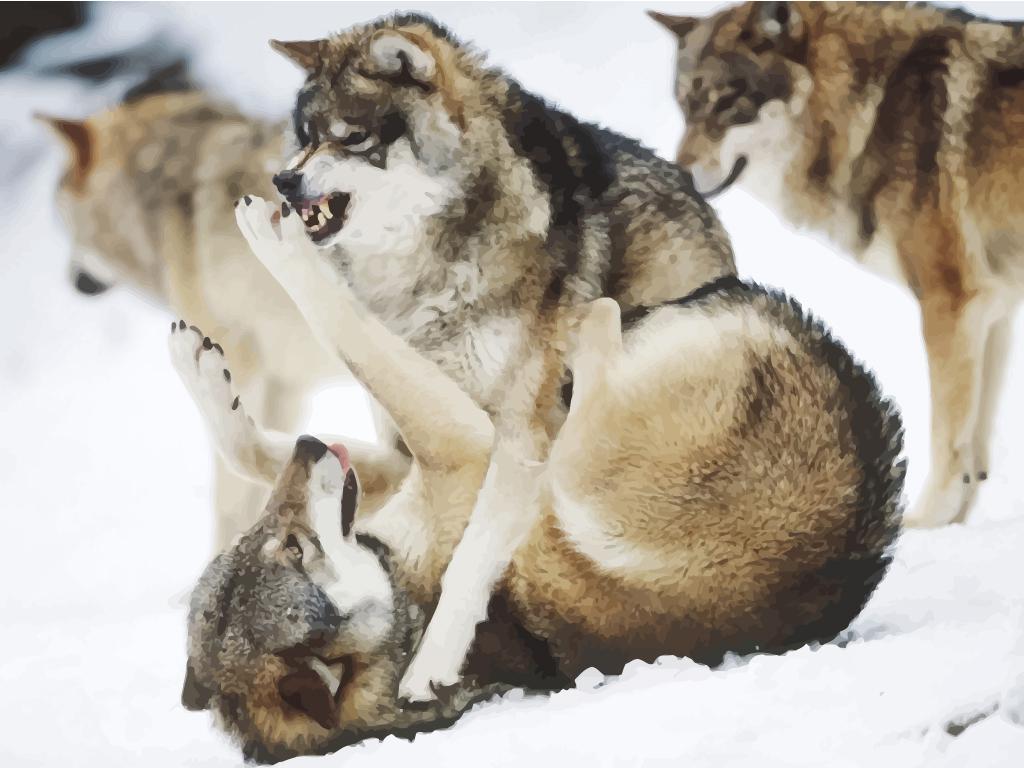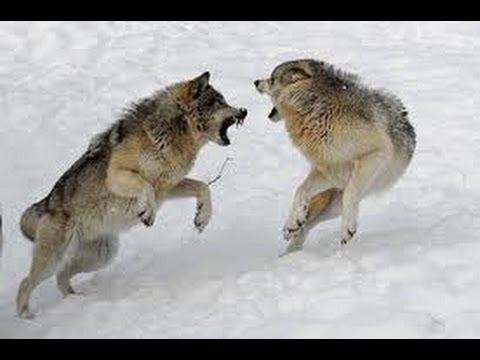The first image is the image on the left, the second image is the image on the right. Evaluate the accuracy of this statement regarding the images: "One image contains no more than one wolf.". Is it true? Answer yes or no. No. The first image is the image on the left, the second image is the image on the right. Analyze the images presented: Is the assertion "All of the wolves are on the snow." valid? Answer yes or no. Yes. 